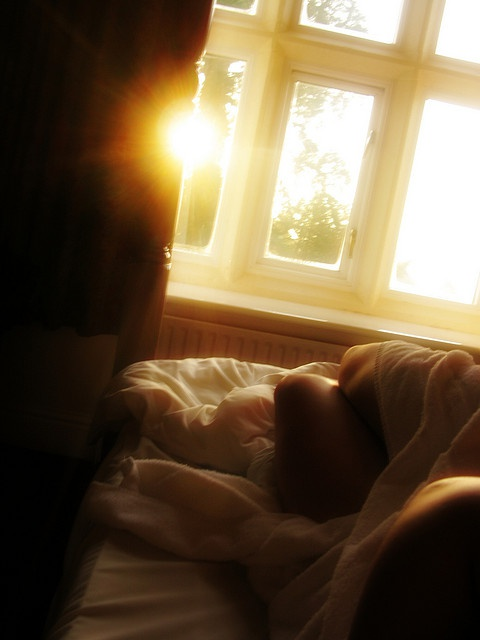Describe the objects in this image and their specific colors. I can see a bed in black, maroon, olive, and tan tones in this image. 